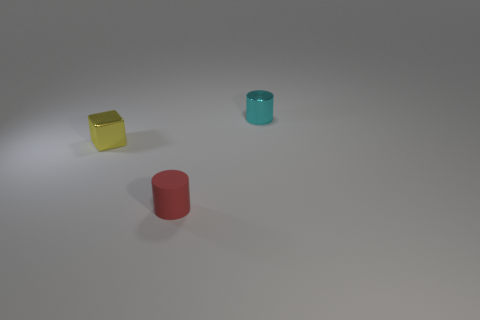If this image is part of a story, what do you think the narrative might be about? If this image is part of a story, it could depict a moment of pause, a scene where characters might interact with these objects in a meaningful way. The arrangement and color of the objects might symbolize choices or personalities, forming a narrative about decision-making or revealing insights about the characters involved. 